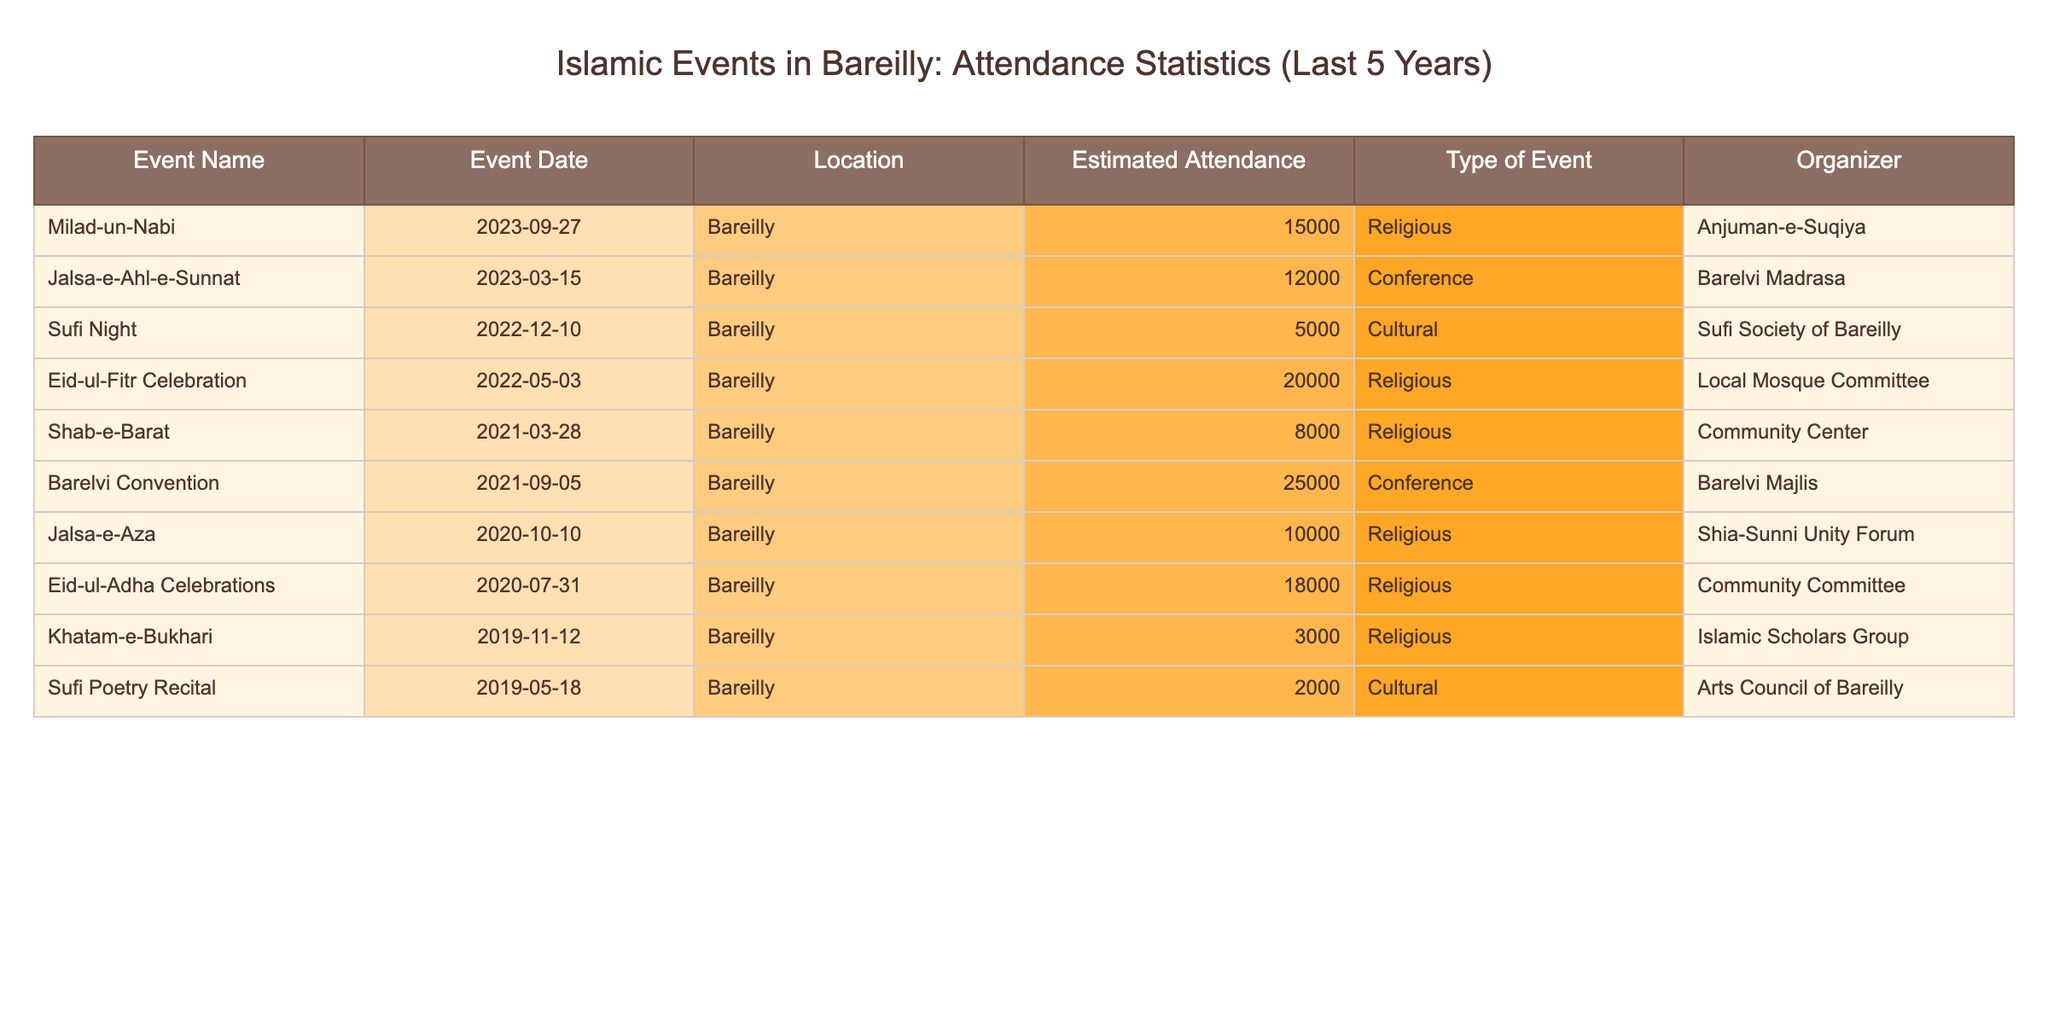What is the estimated attendance for the Eid-ul-Fitr Celebration? The table shows that the estimated attendance for the Eid-ul-Fitr Celebration on 2022-05-03 in Bareilly is 20000.
Answer: 20000 Which event had the highest attendance in the last five years? By checking the estimated attendance numbers, the Barelvi Convention on 2021-09-05 has the highest attendance, with 25000 participants.
Answer: Barelvi Convention How many events had an estimated attendance of over 15000? Looking at the table, there are four events with attendance greater than 15000: Eid-ul-Fitr Celebration (20000), Barelvi Convention (25000), Eid-ul-Adha Celebrations (18000), and Milad-un-Nabi (15000) which counts as one as it's equal to 15000, making it a total of four.
Answer: 4 What was the average attendance of the cultural events listed? The cultural events listed in the table are the Sufi Night (5000) and Sufi Poetry Recital (2000). To find the average, we add these two values (5000 + 2000 = 7000) and divide by 2, giving us an average attendance of 3500.
Answer: 3500 Is it true that all religious events had an attendance of over 10000? By examining the table, we find that several religious events did have attendance over 10000, but the Khatam-e-Bukhari event had only 3000 attendees, making the statement false.
Answer: No How many conferences were held over the last five years and what was their total estimated attendance? From the table, there are two conferences: Jalsa-e-Ahl-e-Sunnat (12000) and Barelvi Convention (25000), making a total of 2 conferences. Their combined attendance is 12000 + 25000 = 37000.
Answer: 2 conferences, 37000 total attendees What was the attendance for the Shab-e-Barat event, and how does it compare to the Sufi Night? The attendance for the Shab-e-Barat event on 2021-03-28 was 8000, whereas the Sufi Night event on 2022-12-10 had 5000 attendees. Comparing these, the Shab-e-Barat had 3000 more attendees than the Sufi Night.
Answer: Shab-e-Barat had 8000, Sufi Night had 5000; 3000 more for Shab-e-Barat What is the total attendance for all events listed in the table? To find the total attendance, we sum all estimated attendance values: 15000 + 12000 + 5000 + 20000 + 8000 + 25000 + 10000 + 18000 + 3000 + 2000 = 111000.
Answer: 111000 